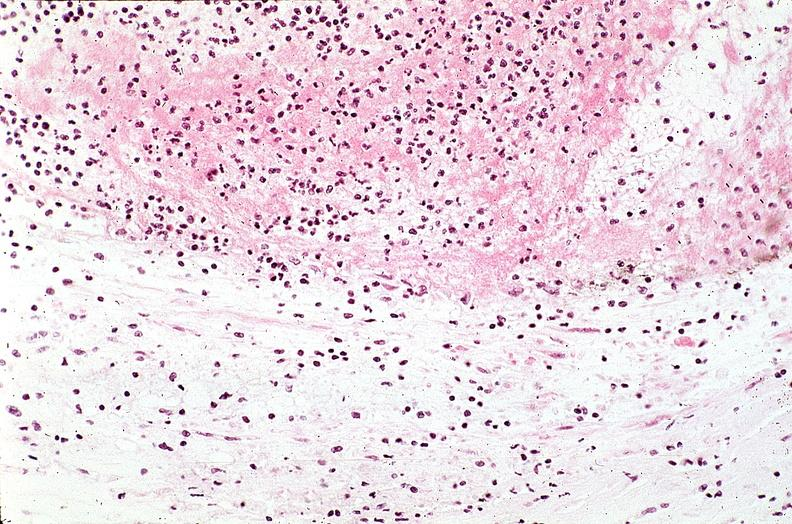s cardiovascular present?
Answer the question using a single word or phrase. Yes 